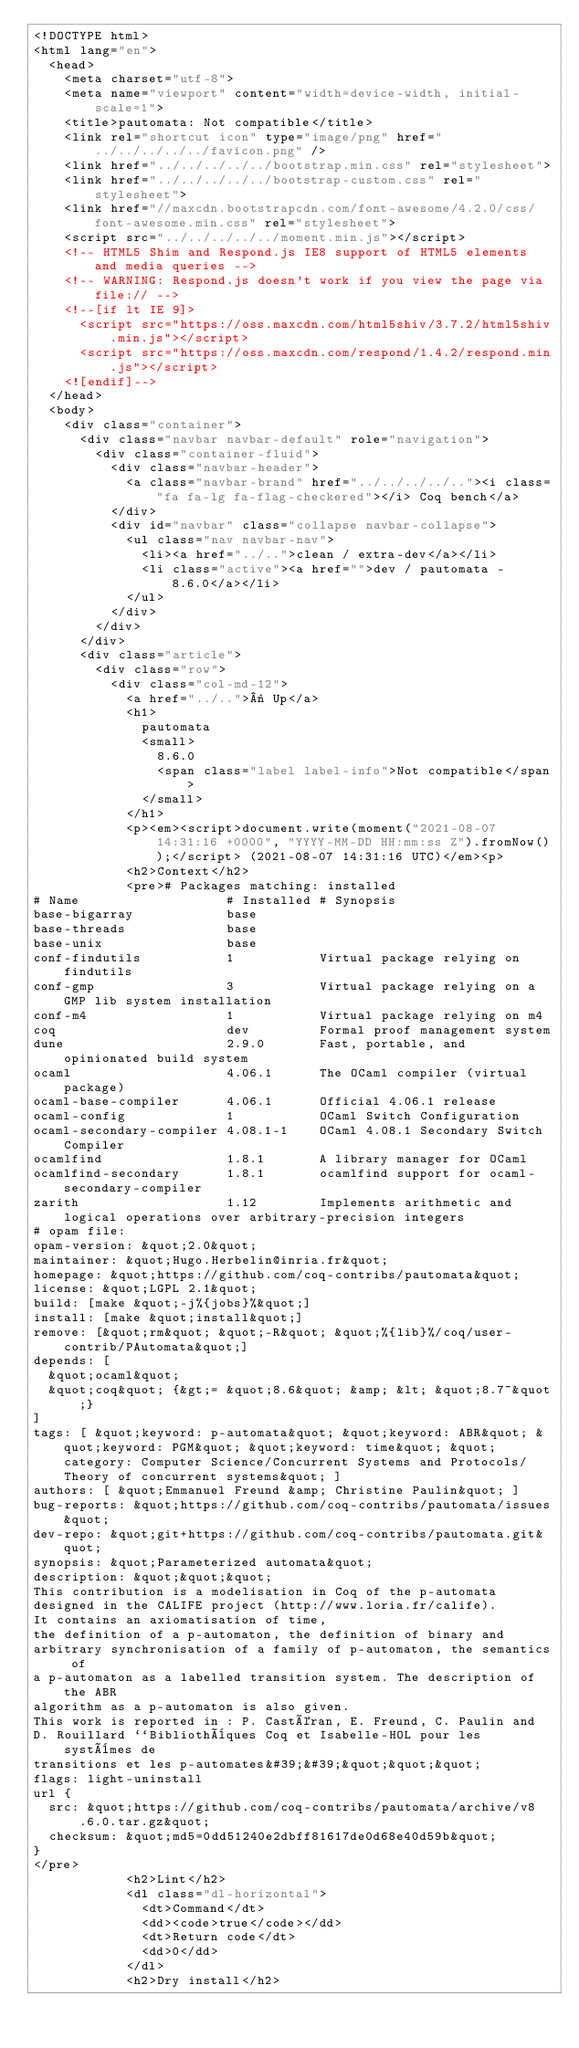Convert code to text. <code><loc_0><loc_0><loc_500><loc_500><_HTML_><!DOCTYPE html>
<html lang="en">
  <head>
    <meta charset="utf-8">
    <meta name="viewport" content="width=device-width, initial-scale=1">
    <title>pautomata: Not compatible</title>
    <link rel="shortcut icon" type="image/png" href="../../../../../favicon.png" />
    <link href="../../../../../bootstrap.min.css" rel="stylesheet">
    <link href="../../../../../bootstrap-custom.css" rel="stylesheet">
    <link href="//maxcdn.bootstrapcdn.com/font-awesome/4.2.0/css/font-awesome.min.css" rel="stylesheet">
    <script src="../../../../../moment.min.js"></script>
    <!-- HTML5 Shim and Respond.js IE8 support of HTML5 elements and media queries -->
    <!-- WARNING: Respond.js doesn't work if you view the page via file:// -->
    <!--[if lt IE 9]>
      <script src="https://oss.maxcdn.com/html5shiv/3.7.2/html5shiv.min.js"></script>
      <script src="https://oss.maxcdn.com/respond/1.4.2/respond.min.js"></script>
    <![endif]-->
  </head>
  <body>
    <div class="container">
      <div class="navbar navbar-default" role="navigation">
        <div class="container-fluid">
          <div class="navbar-header">
            <a class="navbar-brand" href="../../../../.."><i class="fa fa-lg fa-flag-checkered"></i> Coq bench</a>
          </div>
          <div id="navbar" class="collapse navbar-collapse">
            <ul class="nav navbar-nav">
              <li><a href="../..">clean / extra-dev</a></li>
              <li class="active"><a href="">dev / pautomata - 8.6.0</a></li>
            </ul>
          </div>
        </div>
      </div>
      <div class="article">
        <div class="row">
          <div class="col-md-12">
            <a href="../..">« Up</a>
            <h1>
              pautomata
              <small>
                8.6.0
                <span class="label label-info">Not compatible</span>
              </small>
            </h1>
            <p><em><script>document.write(moment("2021-08-07 14:31:16 +0000", "YYYY-MM-DD HH:mm:ss Z").fromNow());</script> (2021-08-07 14:31:16 UTC)</em><p>
            <h2>Context</h2>
            <pre># Packages matching: installed
# Name                   # Installed # Synopsis
base-bigarray            base
base-threads             base
base-unix                base
conf-findutils           1           Virtual package relying on findutils
conf-gmp                 3           Virtual package relying on a GMP lib system installation
conf-m4                  1           Virtual package relying on m4
coq                      dev         Formal proof management system
dune                     2.9.0       Fast, portable, and opinionated build system
ocaml                    4.06.1      The OCaml compiler (virtual package)
ocaml-base-compiler      4.06.1      Official 4.06.1 release
ocaml-config             1           OCaml Switch Configuration
ocaml-secondary-compiler 4.08.1-1    OCaml 4.08.1 Secondary Switch Compiler
ocamlfind                1.8.1       A library manager for OCaml
ocamlfind-secondary      1.8.1       ocamlfind support for ocaml-secondary-compiler
zarith                   1.12        Implements arithmetic and logical operations over arbitrary-precision integers
# opam file:
opam-version: &quot;2.0&quot;
maintainer: &quot;Hugo.Herbelin@inria.fr&quot;
homepage: &quot;https://github.com/coq-contribs/pautomata&quot;
license: &quot;LGPL 2.1&quot;
build: [make &quot;-j%{jobs}%&quot;]
install: [make &quot;install&quot;]
remove: [&quot;rm&quot; &quot;-R&quot; &quot;%{lib}%/coq/user-contrib/PAutomata&quot;]
depends: [
  &quot;ocaml&quot;
  &quot;coq&quot; {&gt;= &quot;8.6&quot; &amp; &lt; &quot;8.7~&quot;}
]
tags: [ &quot;keyword: p-automata&quot; &quot;keyword: ABR&quot; &quot;keyword: PGM&quot; &quot;keyword: time&quot; &quot;category: Computer Science/Concurrent Systems and Protocols/Theory of concurrent systems&quot; ]
authors: [ &quot;Emmanuel Freund &amp; Christine Paulin&quot; ]
bug-reports: &quot;https://github.com/coq-contribs/pautomata/issues&quot;
dev-repo: &quot;git+https://github.com/coq-contribs/pautomata.git&quot;
synopsis: &quot;Parameterized automata&quot;
description: &quot;&quot;&quot;
This contribution is a modelisation in Coq of the p-automata
designed in the CALIFE project (http://www.loria.fr/calife).
It contains an axiomatisation of time,
the definition of a p-automaton, the definition of binary and
arbitrary synchronisation of a family of p-automaton, the semantics of
a p-automaton as a labelled transition system. The description of the ABR
algorithm as a p-automaton is also given.
This work is reported in : P. Castéran, E. Freund, C. Paulin and
D. Rouillard ``Bibliothèques Coq et Isabelle-HOL pour les systèmes de
transitions et les p-automates&#39;&#39;&quot;&quot;&quot;
flags: light-uninstall
url {
  src: &quot;https://github.com/coq-contribs/pautomata/archive/v8.6.0.tar.gz&quot;
  checksum: &quot;md5=0dd51240e2dbff81617de0d68e40d59b&quot;
}
</pre>
            <h2>Lint</h2>
            <dl class="dl-horizontal">
              <dt>Command</dt>
              <dd><code>true</code></dd>
              <dt>Return code</dt>
              <dd>0</dd>
            </dl>
            <h2>Dry install</h2></code> 